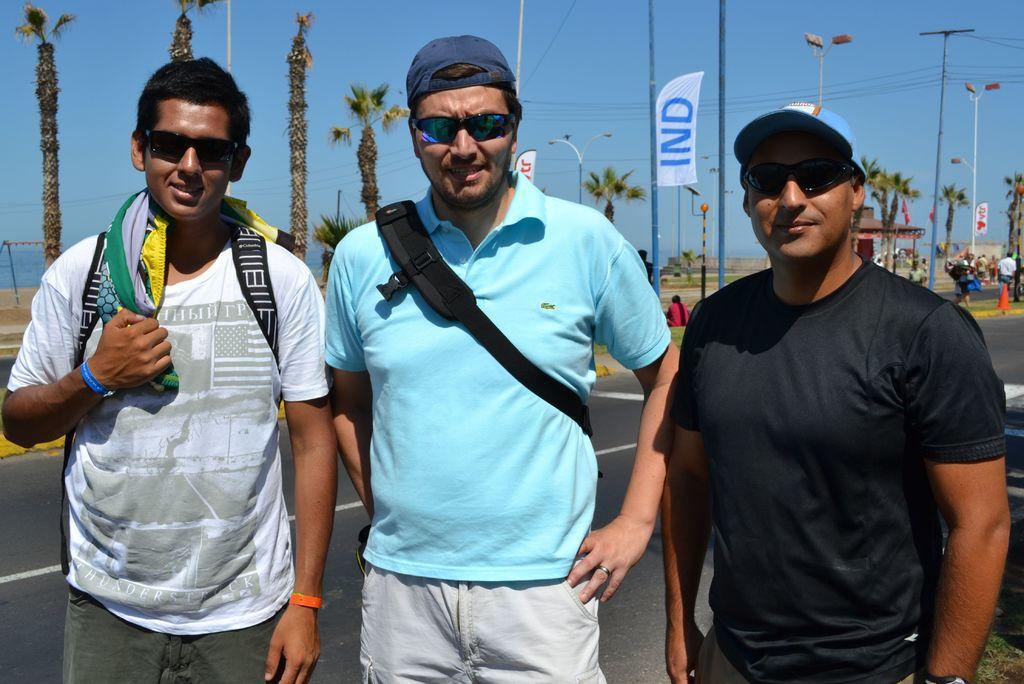Could you give a brief overview of what you see in this image? In this image we can see three people standing on the road with goggles, in the background there are few trees, people, a pole with banner, current pole with wires, street lights, a shed and sky. 